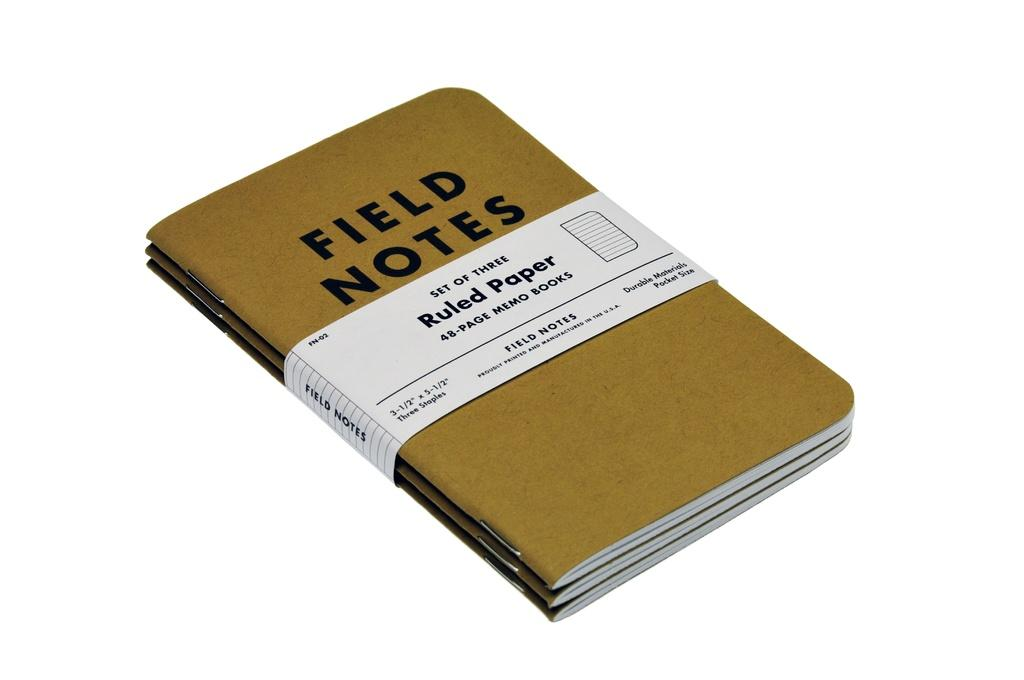<image>
Render a clear and concise summary of the photo. Brown notebook by Field Notes with a set of three ruled papers. 